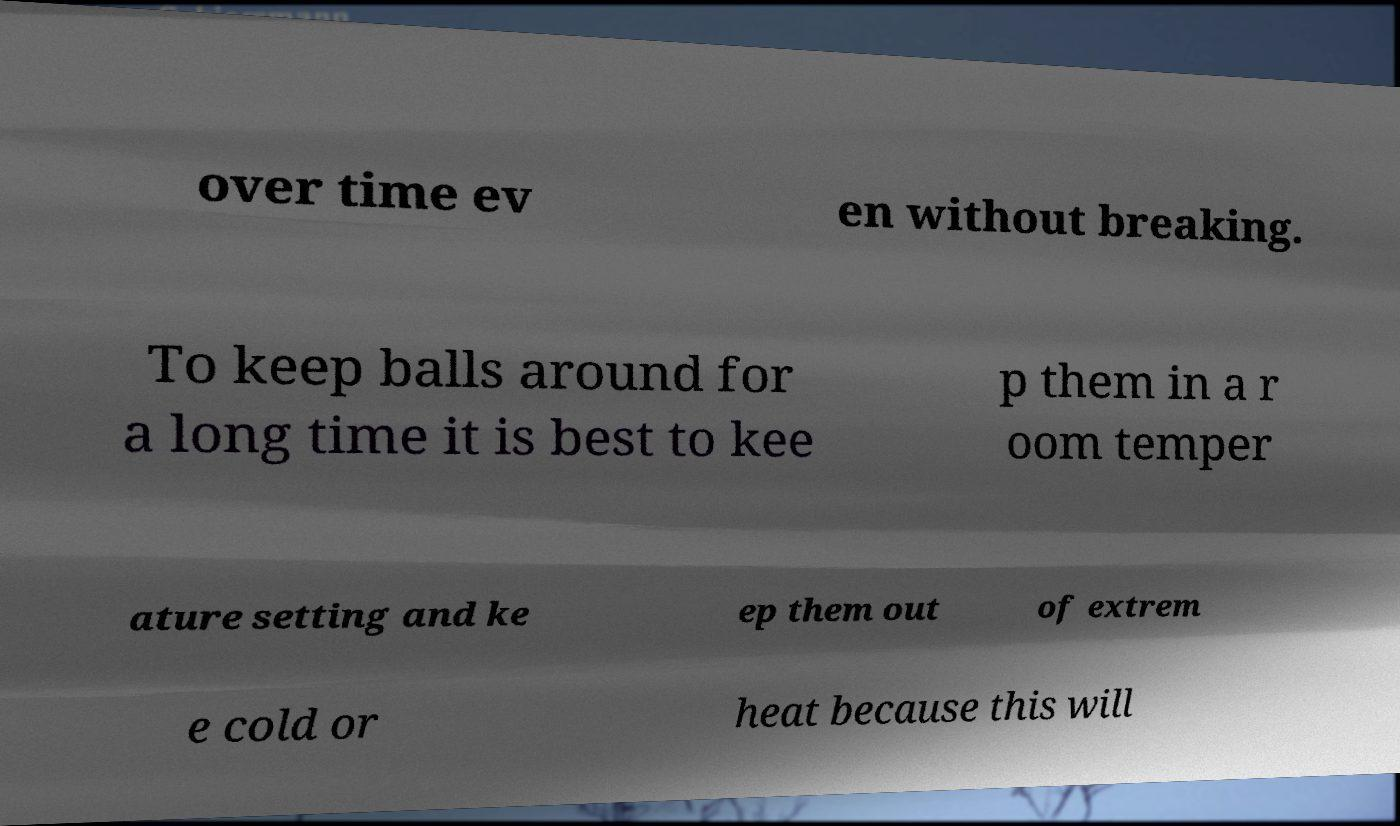Could you assist in decoding the text presented in this image and type it out clearly? over time ev en without breaking. To keep balls around for a long time it is best to kee p them in a r oom temper ature setting and ke ep them out of extrem e cold or heat because this will 